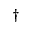<formula> <loc_0><loc_0><loc_500><loc_500>^ { \dag }</formula> 